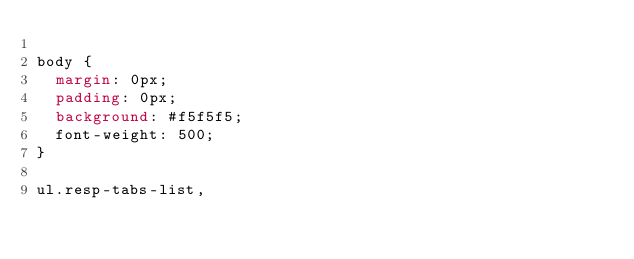Convert code to text. <code><loc_0><loc_0><loc_500><loc_500><_CSS_>
body {
  margin: 0px;
  padding: 0px;
  background: #f5f5f5;
  font-weight: 500;
}

ul.resp-tabs-list,</code> 